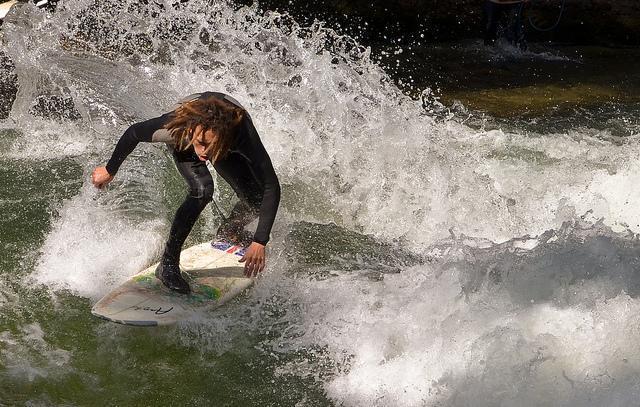How many giraffes are there?
Give a very brief answer. 0. 